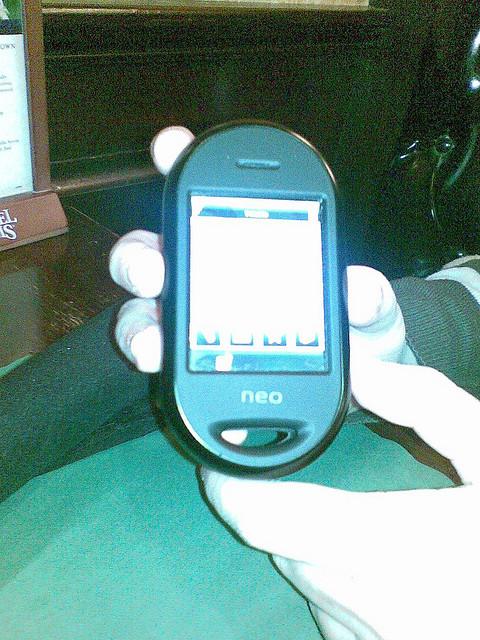How many telephones are here?
Give a very brief answer. 1. What is in the picture?
Short answer required. Cell phone. Do you see a face?
Be succinct. No. 